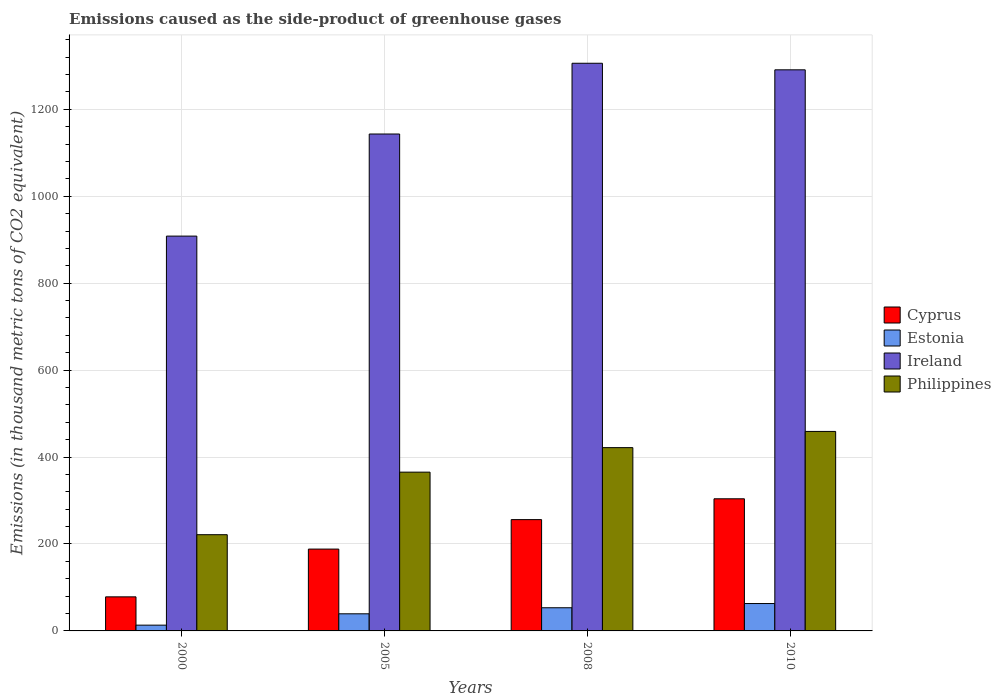Are the number of bars on each tick of the X-axis equal?
Your response must be concise. Yes. How many bars are there on the 1st tick from the left?
Your answer should be very brief. 4. How many bars are there on the 4th tick from the right?
Your response must be concise. 4. What is the label of the 4th group of bars from the left?
Provide a short and direct response. 2010. In how many cases, is the number of bars for a given year not equal to the number of legend labels?
Give a very brief answer. 0. What is the emissions caused as the side-product of greenhouse gases in Philippines in 2005?
Give a very brief answer. 365.3. Across all years, what is the maximum emissions caused as the side-product of greenhouse gases in Philippines?
Provide a short and direct response. 459. Across all years, what is the minimum emissions caused as the side-product of greenhouse gases in Estonia?
Offer a terse response. 13.3. What is the total emissions caused as the side-product of greenhouse gases in Estonia in the graph?
Offer a terse response. 169. What is the difference between the emissions caused as the side-product of greenhouse gases in Ireland in 2000 and that in 2005?
Your response must be concise. -234.9. What is the difference between the emissions caused as the side-product of greenhouse gases in Cyprus in 2008 and the emissions caused as the side-product of greenhouse gases in Estonia in 2010?
Your response must be concise. 193.1. What is the average emissions caused as the side-product of greenhouse gases in Estonia per year?
Give a very brief answer. 42.25. In the year 2005, what is the difference between the emissions caused as the side-product of greenhouse gases in Cyprus and emissions caused as the side-product of greenhouse gases in Estonia?
Ensure brevity in your answer.  148.9. In how many years, is the emissions caused as the side-product of greenhouse gases in Cyprus greater than 960 thousand metric tons?
Offer a terse response. 0. What is the ratio of the emissions caused as the side-product of greenhouse gases in Estonia in 2008 to that in 2010?
Keep it short and to the point. 0.85. Is the difference between the emissions caused as the side-product of greenhouse gases in Cyprus in 2000 and 2010 greater than the difference between the emissions caused as the side-product of greenhouse gases in Estonia in 2000 and 2010?
Your response must be concise. No. What is the difference between the highest and the second highest emissions caused as the side-product of greenhouse gases in Philippines?
Provide a succinct answer. 37.3. What is the difference between the highest and the lowest emissions caused as the side-product of greenhouse gases in Philippines?
Give a very brief answer. 237.6. Is the sum of the emissions caused as the side-product of greenhouse gases in Ireland in 2000 and 2005 greater than the maximum emissions caused as the side-product of greenhouse gases in Estonia across all years?
Make the answer very short. Yes. Is it the case that in every year, the sum of the emissions caused as the side-product of greenhouse gases in Estonia and emissions caused as the side-product of greenhouse gases in Cyprus is greater than the sum of emissions caused as the side-product of greenhouse gases in Ireland and emissions caused as the side-product of greenhouse gases in Philippines?
Keep it short and to the point. Yes. What does the 2nd bar from the left in 2010 represents?
Your answer should be very brief. Estonia. What does the 3rd bar from the right in 2000 represents?
Ensure brevity in your answer.  Estonia. Are all the bars in the graph horizontal?
Make the answer very short. No. How many years are there in the graph?
Offer a very short reply. 4. Are the values on the major ticks of Y-axis written in scientific E-notation?
Provide a succinct answer. No. Does the graph contain any zero values?
Your response must be concise. No. Where does the legend appear in the graph?
Make the answer very short. Center right. What is the title of the graph?
Give a very brief answer. Emissions caused as the side-product of greenhouse gases. What is the label or title of the Y-axis?
Your response must be concise. Emissions (in thousand metric tons of CO2 equivalent). What is the Emissions (in thousand metric tons of CO2 equivalent) of Cyprus in 2000?
Provide a succinct answer. 78.4. What is the Emissions (in thousand metric tons of CO2 equivalent) of Ireland in 2000?
Your answer should be very brief. 908.4. What is the Emissions (in thousand metric tons of CO2 equivalent) in Philippines in 2000?
Offer a very short reply. 221.4. What is the Emissions (in thousand metric tons of CO2 equivalent) in Cyprus in 2005?
Provide a succinct answer. 188.3. What is the Emissions (in thousand metric tons of CO2 equivalent) in Estonia in 2005?
Your answer should be compact. 39.4. What is the Emissions (in thousand metric tons of CO2 equivalent) of Ireland in 2005?
Keep it short and to the point. 1143.3. What is the Emissions (in thousand metric tons of CO2 equivalent) of Philippines in 2005?
Provide a short and direct response. 365.3. What is the Emissions (in thousand metric tons of CO2 equivalent) in Cyprus in 2008?
Give a very brief answer. 256.1. What is the Emissions (in thousand metric tons of CO2 equivalent) in Estonia in 2008?
Your answer should be compact. 53.3. What is the Emissions (in thousand metric tons of CO2 equivalent) in Ireland in 2008?
Offer a terse response. 1306.1. What is the Emissions (in thousand metric tons of CO2 equivalent) in Philippines in 2008?
Ensure brevity in your answer.  421.7. What is the Emissions (in thousand metric tons of CO2 equivalent) of Cyprus in 2010?
Your answer should be very brief. 304. What is the Emissions (in thousand metric tons of CO2 equivalent) in Ireland in 2010?
Offer a terse response. 1291. What is the Emissions (in thousand metric tons of CO2 equivalent) in Philippines in 2010?
Provide a succinct answer. 459. Across all years, what is the maximum Emissions (in thousand metric tons of CO2 equivalent) in Cyprus?
Provide a short and direct response. 304. Across all years, what is the maximum Emissions (in thousand metric tons of CO2 equivalent) of Ireland?
Provide a succinct answer. 1306.1. Across all years, what is the maximum Emissions (in thousand metric tons of CO2 equivalent) of Philippines?
Provide a short and direct response. 459. Across all years, what is the minimum Emissions (in thousand metric tons of CO2 equivalent) of Cyprus?
Your answer should be compact. 78.4. Across all years, what is the minimum Emissions (in thousand metric tons of CO2 equivalent) in Ireland?
Your answer should be very brief. 908.4. Across all years, what is the minimum Emissions (in thousand metric tons of CO2 equivalent) of Philippines?
Offer a very short reply. 221.4. What is the total Emissions (in thousand metric tons of CO2 equivalent) in Cyprus in the graph?
Ensure brevity in your answer.  826.8. What is the total Emissions (in thousand metric tons of CO2 equivalent) in Estonia in the graph?
Your answer should be compact. 169. What is the total Emissions (in thousand metric tons of CO2 equivalent) in Ireland in the graph?
Provide a succinct answer. 4648.8. What is the total Emissions (in thousand metric tons of CO2 equivalent) of Philippines in the graph?
Give a very brief answer. 1467.4. What is the difference between the Emissions (in thousand metric tons of CO2 equivalent) in Cyprus in 2000 and that in 2005?
Make the answer very short. -109.9. What is the difference between the Emissions (in thousand metric tons of CO2 equivalent) in Estonia in 2000 and that in 2005?
Offer a very short reply. -26.1. What is the difference between the Emissions (in thousand metric tons of CO2 equivalent) of Ireland in 2000 and that in 2005?
Make the answer very short. -234.9. What is the difference between the Emissions (in thousand metric tons of CO2 equivalent) of Philippines in 2000 and that in 2005?
Ensure brevity in your answer.  -143.9. What is the difference between the Emissions (in thousand metric tons of CO2 equivalent) of Cyprus in 2000 and that in 2008?
Make the answer very short. -177.7. What is the difference between the Emissions (in thousand metric tons of CO2 equivalent) of Ireland in 2000 and that in 2008?
Your answer should be very brief. -397.7. What is the difference between the Emissions (in thousand metric tons of CO2 equivalent) in Philippines in 2000 and that in 2008?
Offer a terse response. -200.3. What is the difference between the Emissions (in thousand metric tons of CO2 equivalent) of Cyprus in 2000 and that in 2010?
Your response must be concise. -225.6. What is the difference between the Emissions (in thousand metric tons of CO2 equivalent) of Estonia in 2000 and that in 2010?
Offer a terse response. -49.7. What is the difference between the Emissions (in thousand metric tons of CO2 equivalent) in Ireland in 2000 and that in 2010?
Provide a succinct answer. -382.6. What is the difference between the Emissions (in thousand metric tons of CO2 equivalent) in Philippines in 2000 and that in 2010?
Make the answer very short. -237.6. What is the difference between the Emissions (in thousand metric tons of CO2 equivalent) of Cyprus in 2005 and that in 2008?
Your answer should be very brief. -67.8. What is the difference between the Emissions (in thousand metric tons of CO2 equivalent) of Estonia in 2005 and that in 2008?
Keep it short and to the point. -13.9. What is the difference between the Emissions (in thousand metric tons of CO2 equivalent) in Ireland in 2005 and that in 2008?
Provide a short and direct response. -162.8. What is the difference between the Emissions (in thousand metric tons of CO2 equivalent) of Philippines in 2005 and that in 2008?
Ensure brevity in your answer.  -56.4. What is the difference between the Emissions (in thousand metric tons of CO2 equivalent) of Cyprus in 2005 and that in 2010?
Make the answer very short. -115.7. What is the difference between the Emissions (in thousand metric tons of CO2 equivalent) in Estonia in 2005 and that in 2010?
Make the answer very short. -23.6. What is the difference between the Emissions (in thousand metric tons of CO2 equivalent) in Ireland in 2005 and that in 2010?
Ensure brevity in your answer.  -147.7. What is the difference between the Emissions (in thousand metric tons of CO2 equivalent) in Philippines in 2005 and that in 2010?
Ensure brevity in your answer.  -93.7. What is the difference between the Emissions (in thousand metric tons of CO2 equivalent) in Cyprus in 2008 and that in 2010?
Keep it short and to the point. -47.9. What is the difference between the Emissions (in thousand metric tons of CO2 equivalent) in Estonia in 2008 and that in 2010?
Provide a succinct answer. -9.7. What is the difference between the Emissions (in thousand metric tons of CO2 equivalent) in Ireland in 2008 and that in 2010?
Provide a succinct answer. 15.1. What is the difference between the Emissions (in thousand metric tons of CO2 equivalent) of Philippines in 2008 and that in 2010?
Offer a very short reply. -37.3. What is the difference between the Emissions (in thousand metric tons of CO2 equivalent) in Cyprus in 2000 and the Emissions (in thousand metric tons of CO2 equivalent) in Estonia in 2005?
Your answer should be very brief. 39. What is the difference between the Emissions (in thousand metric tons of CO2 equivalent) in Cyprus in 2000 and the Emissions (in thousand metric tons of CO2 equivalent) in Ireland in 2005?
Keep it short and to the point. -1064.9. What is the difference between the Emissions (in thousand metric tons of CO2 equivalent) in Cyprus in 2000 and the Emissions (in thousand metric tons of CO2 equivalent) in Philippines in 2005?
Provide a short and direct response. -286.9. What is the difference between the Emissions (in thousand metric tons of CO2 equivalent) in Estonia in 2000 and the Emissions (in thousand metric tons of CO2 equivalent) in Ireland in 2005?
Your answer should be compact. -1130. What is the difference between the Emissions (in thousand metric tons of CO2 equivalent) in Estonia in 2000 and the Emissions (in thousand metric tons of CO2 equivalent) in Philippines in 2005?
Make the answer very short. -352. What is the difference between the Emissions (in thousand metric tons of CO2 equivalent) of Ireland in 2000 and the Emissions (in thousand metric tons of CO2 equivalent) of Philippines in 2005?
Ensure brevity in your answer.  543.1. What is the difference between the Emissions (in thousand metric tons of CO2 equivalent) of Cyprus in 2000 and the Emissions (in thousand metric tons of CO2 equivalent) of Estonia in 2008?
Your answer should be compact. 25.1. What is the difference between the Emissions (in thousand metric tons of CO2 equivalent) in Cyprus in 2000 and the Emissions (in thousand metric tons of CO2 equivalent) in Ireland in 2008?
Your answer should be very brief. -1227.7. What is the difference between the Emissions (in thousand metric tons of CO2 equivalent) of Cyprus in 2000 and the Emissions (in thousand metric tons of CO2 equivalent) of Philippines in 2008?
Offer a very short reply. -343.3. What is the difference between the Emissions (in thousand metric tons of CO2 equivalent) of Estonia in 2000 and the Emissions (in thousand metric tons of CO2 equivalent) of Ireland in 2008?
Keep it short and to the point. -1292.8. What is the difference between the Emissions (in thousand metric tons of CO2 equivalent) of Estonia in 2000 and the Emissions (in thousand metric tons of CO2 equivalent) of Philippines in 2008?
Keep it short and to the point. -408.4. What is the difference between the Emissions (in thousand metric tons of CO2 equivalent) in Ireland in 2000 and the Emissions (in thousand metric tons of CO2 equivalent) in Philippines in 2008?
Your answer should be very brief. 486.7. What is the difference between the Emissions (in thousand metric tons of CO2 equivalent) in Cyprus in 2000 and the Emissions (in thousand metric tons of CO2 equivalent) in Ireland in 2010?
Make the answer very short. -1212.6. What is the difference between the Emissions (in thousand metric tons of CO2 equivalent) of Cyprus in 2000 and the Emissions (in thousand metric tons of CO2 equivalent) of Philippines in 2010?
Offer a terse response. -380.6. What is the difference between the Emissions (in thousand metric tons of CO2 equivalent) in Estonia in 2000 and the Emissions (in thousand metric tons of CO2 equivalent) in Ireland in 2010?
Give a very brief answer. -1277.7. What is the difference between the Emissions (in thousand metric tons of CO2 equivalent) of Estonia in 2000 and the Emissions (in thousand metric tons of CO2 equivalent) of Philippines in 2010?
Offer a terse response. -445.7. What is the difference between the Emissions (in thousand metric tons of CO2 equivalent) in Ireland in 2000 and the Emissions (in thousand metric tons of CO2 equivalent) in Philippines in 2010?
Your answer should be very brief. 449.4. What is the difference between the Emissions (in thousand metric tons of CO2 equivalent) of Cyprus in 2005 and the Emissions (in thousand metric tons of CO2 equivalent) of Estonia in 2008?
Make the answer very short. 135. What is the difference between the Emissions (in thousand metric tons of CO2 equivalent) of Cyprus in 2005 and the Emissions (in thousand metric tons of CO2 equivalent) of Ireland in 2008?
Make the answer very short. -1117.8. What is the difference between the Emissions (in thousand metric tons of CO2 equivalent) in Cyprus in 2005 and the Emissions (in thousand metric tons of CO2 equivalent) in Philippines in 2008?
Provide a short and direct response. -233.4. What is the difference between the Emissions (in thousand metric tons of CO2 equivalent) in Estonia in 2005 and the Emissions (in thousand metric tons of CO2 equivalent) in Ireland in 2008?
Provide a short and direct response. -1266.7. What is the difference between the Emissions (in thousand metric tons of CO2 equivalent) in Estonia in 2005 and the Emissions (in thousand metric tons of CO2 equivalent) in Philippines in 2008?
Make the answer very short. -382.3. What is the difference between the Emissions (in thousand metric tons of CO2 equivalent) in Ireland in 2005 and the Emissions (in thousand metric tons of CO2 equivalent) in Philippines in 2008?
Make the answer very short. 721.6. What is the difference between the Emissions (in thousand metric tons of CO2 equivalent) of Cyprus in 2005 and the Emissions (in thousand metric tons of CO2 equivalent) of Estonia in 2010?
Your response must be concise. 125.3. What is the difference between the Emissions (in thousand metric tons of CO2 equivalent) of Cyprus in 2005 and the Emissions (in thousand metric tons of CO2 equivalent) of Ireland in 2010?
Provide a succinct answer. -1102.7. What is the difference between the Emissions (in thousand metric tons of CO2 equivalent) in Cyprus in 2005 and the Emissions (in thousand metric tons of CO2 equivalent) in Philippines in 2010?
Your answer should be compact. -270.7. What is the difference between the Emissions (in thousand metric tons of CO2 equivalent) in Estonia in 2005 and the Emissions (in thousand metric tons of CO2 equivalent) in Ireland in 2010?
Your answer should be very brief. -1251.6. What is the difference between the Emissions (in thousand metric tons of CO2 equivalent) in Estonia in 2005 and the Emissions (in thousand metric tons of CO2 equivalent) in Philippines in 2010?
Offer a terse response. -419.6. What is the difference between the Emissions (in thousand metric tons of CO2 equivalent) of Ireland in 2005 and the Emissions (in thousand metric tons of CO2 equivalent) of Philippines in 2010?
Your response must be concise. 684.3. What is the difference between the Emissions (in thousand metric tons of CO2 equivalent) of Cyprus in 2008 and the Emissions (in thousand metric tons of CO2 equivalent) of Estonia in 2010?
Keep it short and to the point. 193.1. What is the difference between the Emissions (in thousand metric tons of CO2 equivalent) in Cyprus in 2008 and the Emissions (in thousand metric tons of CO2 equivalent) in Ireland in 2010?
Your answer should be compact. -1034.9. What is the difference between the Emissions (in thousand metric tons of CO2 equivalent) in Cyprus in 2008 and the Emissions (in thousand metric tons of CO2 equivalent) in Philippines in 2010?
Provide a succinct answer. -202.9. What is the difference between the Emissions (in thousand metric tons of CO2 equivalent) in Estonia in 2008 and the Emissions (in thousand metric tons of CO2 equivalent) in Ireland in 2010?
Your answer should be very brief. -1237.7. What is the difference between the Emissions (in thousand metric tons of CO2 equivalent) of Estonia in 2008 and the Emissions (in thousand metric tons of CO2 equivalent) of Philippines in 2010?
Offer a very short reply. -405.7. What is the difference between the Emissions (in thousand metric tons of CO2 equivalent) in Ireland in 2008 and the Emissions (in thousand metric tons of CO2 equivalent) in Philippines in 2010?
Ensure brevity in your answer.  847.1. What is the average Emissions (in thousand metric tons of CO2 equivalent) of Cyprus per year?
Offer a very short reply. 206.7. What is the average Emissions (in thousand metric tons of CO2 equivalent) in Estonia per year?
Provide a short and direct response. 42.25. What is the average Emissions (in thousand metric tons of CO2 equivalent) of Ireland per year?
Ensure brevity in your answer.  1162.2. What is the average Emissions (in thousand metric tons of CO2 equivalent) in Philippines per year?
Ensure brevity in your answer.  366.85. In the year 2000, what is the difference between the Emissions (in thousand metric tons of CO2 equivalent) in Cyprus and Emissions (in thousand metric tons of CO2 equivalent) in Estonia?
Offer a very short reply. 65.1. In the year 2000, what is the difference between the Emissions (in thousand metric tons of CO2 equivalent) of Cyprus and Emissions (in thousand metric tons of CO2 equivalent) of Ireland?
Make the answer very short. -830. In the year 2000, what is the difference between the Emissions (in thousand metric tons of CO2 equivalent) in Cyprus and Emissions (in thousand metric tons of CO2 equivalent) in Philippines?
Provide a succinct answer. -143. In the year 2000, what is the difference between the Emissions (in thousand metric tons of CO2 equivalent) of Estonia and Emissions (in thousand metric tons of CO2 equivalent) of Ireland?
Make the answer very short. -895.1. In the year 2000, what is the difference between the Emissions (in thousand metric tons of CO2 equivalent) in Estonia and Emissions (in thousand metric tons of CO2 equivalent) in Philippines?
Give a very brief answer. -208.1. In the year 2000, what is the difference between the Emissions (in thousand metric tons of CO2 equivalent) in Ireland and Emissions (in thousand metric tons of CO2 equivalent) in Philippines?
Your answer should be compact. 687. In the year 2005, what is the difference between the Emissions (in thousand metric tons of CO2 equivalent) of Cyprus and Emissions (in thousand metric tons of CO2 equivalent) of Estonia?
Make the answer very short. 148.9. In the year 2005, what is the difference between the Emissions (in thousand metric tons of CO2 equivalent) in Cyprus and Emissions (in thousand metric tons of CO2 equivalent) in Ireland?
Provide a succinct answer. -955. In the year 2005, what is the difference between the Emissions (in thousand metric tons of CO2 equivalent) of Cyprus and Emissions (in thousand metric tons of CO2 equivalent) of Philippines?
Your response must be concise. -177. In the year 2005, what is the difference between the Emissions (in thousand metric tons of CO2 equivalent) in Estonia and Emissions (in thousand metric tons of CO2 equivalent) in Ireland?
Offer a terse response. -1103.9. In the year 2005, what is the difference between the Emissions (in thousand metric tons of CO2 equivalent) of Estonia and Emissions (in thousand metric tons of CO2 equivalent) of Philippines?
Your answer should be compact. -325.9. In the year 2005, what is the difference between the Emissions (in thousand metric tons of CO2 equivalent) in Ireland and Emissions (in thousand metric tons of CO2 equivalent) in Philippines?
Your answer should be very brief. 778. In the year 2008, what is the difference between the Emissions (in thousand metric tons of CO2 equivalent) in Cyprus and Emissions (in thousand metric tons of CO2 equivalent) in Estonia?
Your answer should be very brief. 202.8. In the year 2008, what is the difference between the Emissions (in thousand metric tons of CO2 equivalent) in Cyprus and Emissions (in thousand metric tons of CO2 equivalent) in Ireland?
Your response must be concise. -1050. In the year 2008, what is the difference between the Emissions (in thousand metric tons of CO2 equivalent) of Cyprus and Emissions (in thousand metric tons of CO2 equivalent) of Philippines?
Give a very brief answer. -165.6. In the year 2008, what is the difference between the Emissions (in thousand metric tons of CO2 equivalent) of Estonia and Emissions (in thousand metric tons of CO2 equivalent) of Ireland?
Provide a succinct answer. -1252.8. In the year 2008, what is the difference between the Emissions (in thousand metric tons of CO2 equivalent) of Estonia and Emissions (in thousand metric tons of CO2 equivalent) of Philippines?
Offer a terse response. -368.4. In the year 2008, what is the difference between the Emissions (in thousand metric tons of CO2 equivalent) of Ireland and Emissions (in thousand metric tons of CO2 equivalent) of Philippines?
Give a very brief answer. 884.4. In the year 2010, what is the difference between the Emissions (in thousand metric tons of CO2 equivalent) in Cyprus and Emissions (in thousand metric tons of CO2 equivalent) in Estonia?
Provide a succinct answer. 241. In the year 2010, what is the difference between the Emissions (in thousand metric tons of CO2 equivalent) of Cyprus and Emissions (in thousand metric tons of CO2 equivalent) of Ireland?
Provide a short and direct response. -987. In the year 2010, what is the difference between the Emissions (in thousand metric tons of CO2 equivalent) of Cyprus and Emissions (in thousand metric tons of CO2 equivalent) of Philippines?
Offer a terse response. -155. In the year 2010, what is the difference between the Emissions (in thousand metric tons of CO2 equivalent) in Estonia and Emissions (in thousand metric tons of CO2 equivalent) in Ireland?
Keep it short and to the point. -1228. In the year 2010, what is the difference between the Emissions (in thousand metric tons of CO2 equivalent) in Estonia and Emissions (in thousand metric tons of CO2 equivalent) in Philippines?
Give a very brief answer. -396. In the year 2010, what is the difference between the Emissions (in thousand metric tons of CO2 equivalent) in Ireland and Emissions (in thousand metric tons of CO2 equivalent) in Philippines?
Your answer should be very brief. 832. What is the ratio of the Emissions (in thousand metric tons of CO2 equivalent) of Cyprus in 2000 to that in 2005?
Give a very brief answer. 0.42. What is the ratio of the Emissions (in thousand metric tons of CO2 equivalent) of Estonia in 2000 to that in 2005?
Your answer should be compact. 0.34. What is the ratio of the Emissions (in thousand metric tons of CO2 equivalent) in Ireland in 2000 to that in 2005?
Your answer should be very brief. 0.79. What is the ratio of the Emissions (in thousand metric tons of CO2 equivalent) in Philippines in 2000 to that in 2005?
Keep it short and to the point. 0.61. What is the ratio of the Emissions (in thousand metric tons of CO2 equivalent) of Cyprus in 2000 to that in 2008?
Offer a terse response. 0.31. What is the ratio of the Emissions (in thousand metric tons of CO2 equivalent) in Estonia in 2000 to that in 2008?
Your answer should be very brief. 0.25. What is the ratio of the Emissions (in thousand metric tons of CO2 equivalent) in Ireland in 2000 to that in 2008?
Keep it short and to the point. 0.7. What is the ratio of the Emissions (in thousand metric tons of CO2 equivalent) of Philippines in 2000 to that in 2008?
Give a very brief answer. 0.53. What is the ratio of the Emissions (in thousand metric tons of CO2 equivalent) of Cyprus in 2000 to that in 2010?
Give a very brief answer. 0.26. What is the ratio of the Emissions (in thousand metric tons of CO2 equivalent) of Estonia in 2000 to that in 2010?
Ensure brevity in your answer.  0.21. What is the ratio of the Emissions (in thousand metric tons of CO2 equivalent) in Ireland in 2000 to that in 2010?
Keep it short and to the point. 0.7. What is the ratio of the Emissions (in thousand metric tons of CO2 equivalent) in Philippines in 2000 to that in 2010?
Offer a terse response. 0.48. What is the ratio of the Emissions (in thousand metric tons of CO2 equivalent) of Cyprus in 2005 to that in 2008?
Ensure brevity in your answer.  0.74. What is the ratio of the Emissions (in thousand metric tons of CO2 equivalent) in Estonia in 2005 to that in 2008?
Offer a terse response. 0.74. What is the ratio of the Emissions (in thousand metric tons of CO2 equivalent) in Ireland in 2005 to that in 2008?
Provide a succinct answer. 0.88. What is the ratio of the Emissions (in thousand metric tons of CO2 equivalent) of Philippines in 2005 to that in 2008?
Your answer should be compact. 0.87. What is the ratio of the Emissions (in thousand metric tons of CO2 equivalent) of Cyprus in 2005 to that in 2010?
Make the answer very short. 0.62. What is the ratio of the Emissions (in thousand metric tons of CO2 equivalent) in Estonia in 2005 to that in 2010?
Offer a terse response. 0.63. What is the ratio of the Emissions (in thousand metric tons of CO2 equivalent) of Ireland in 2005 to that in 2010?
Your answer should be very brief. 0.89. What is the ratio of the Emissions (in thousand metric tons of CO2 equivalent) of Philippines in 2005 to that in 2010?
Make the answer very short. 0.8. What is the ratio of the Emissions (in thousand metric tons of CO2 equivalent) in Cyprus in 2008 to that in 2010?
Your response must be concise. 0.84. What is the ratio of the Emissions (in thousand metric tons of CO2 equivalent) in Estonia in 2008 to that in 2010?
Keep it short and to the point. 0.85. What is the ratio of the Emissions (in thousand metric tons of CO2 equivalent) in Ireland in 2008 to that in 2010?
Offer a terse response. 1.01. What is the ratio of the Emissions (in thousand metric tons of CO2 equivalent) of Philippines in 2008 to that in 2010?
Your answer should be compact. 0.92. What is the difference between the highest and the second highest Emissions (in thousand metric tons of CO2 equivalent) in Cyprus?
Offer a terse response. 47.9. What is the difference between the highest and the second highest Emissions (in thousand metric tons of CO2 equivalent) of Philippines?
Offer a terse response. 37.3. What is the difference between the highest and the lowest Emissions (in thousand metric tons of CO2 equivalent) in Cyprus?
Provide a short and direct response. 225.6. What is the difference between the highest and the lowest Emissions (in thousand metric tons of CO2 equivalent) of Estonia?
Provide a succinct answer. 49.7. What is the difference between the highest and the lowest Emissions (in thousand metric tons of CO2 equivalent) in Ireland?
Keep it short and to the point. 397.7. What is the difference between the highest and the lowest Emissions (in thousand metric tons of CO2 equivalent) in Philippines?
Provide a succinct answer. 237.6. 